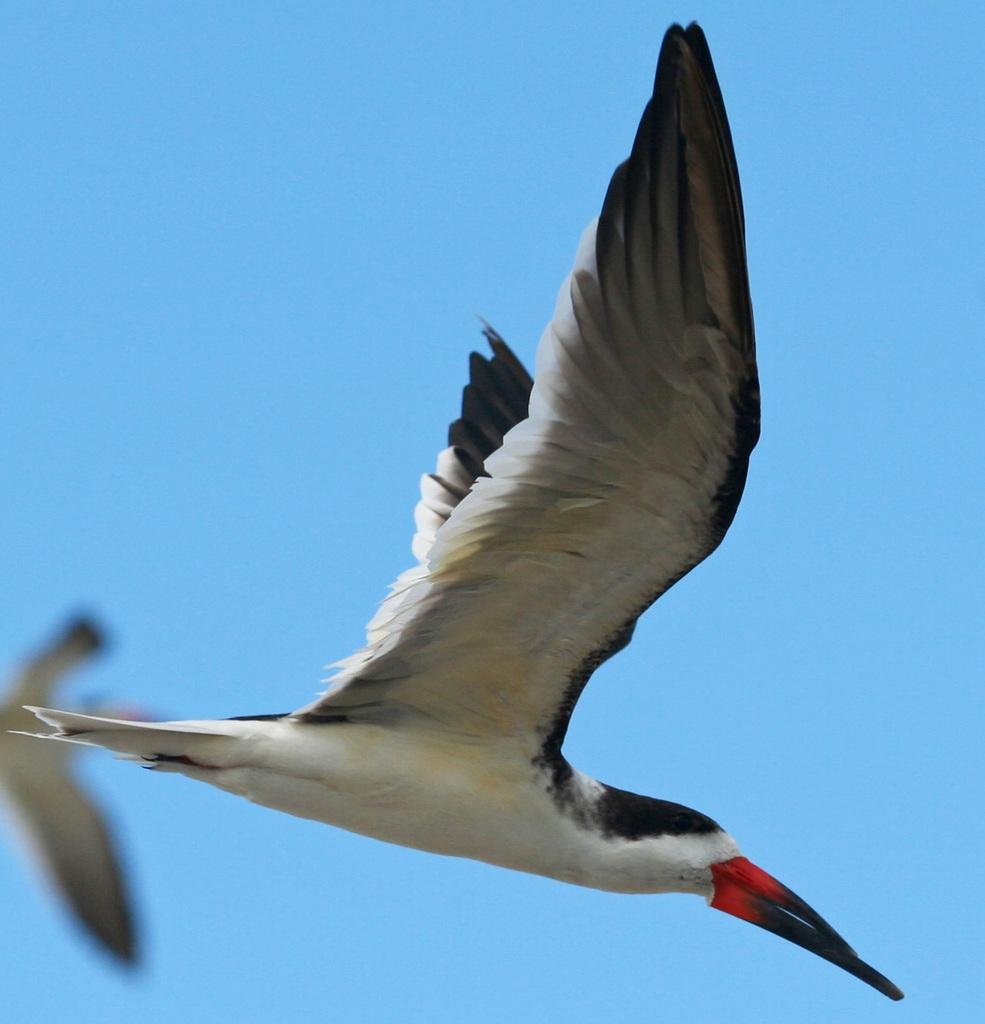What type of bird is in the image? There is a black skimmer in the image. What is the black skimmer doing in the image? The black skimmer is flying in the air. What is the boy teaching the black skimmer in the image? There is no boy present in the image, and therefore no teaching activity can be observed. 